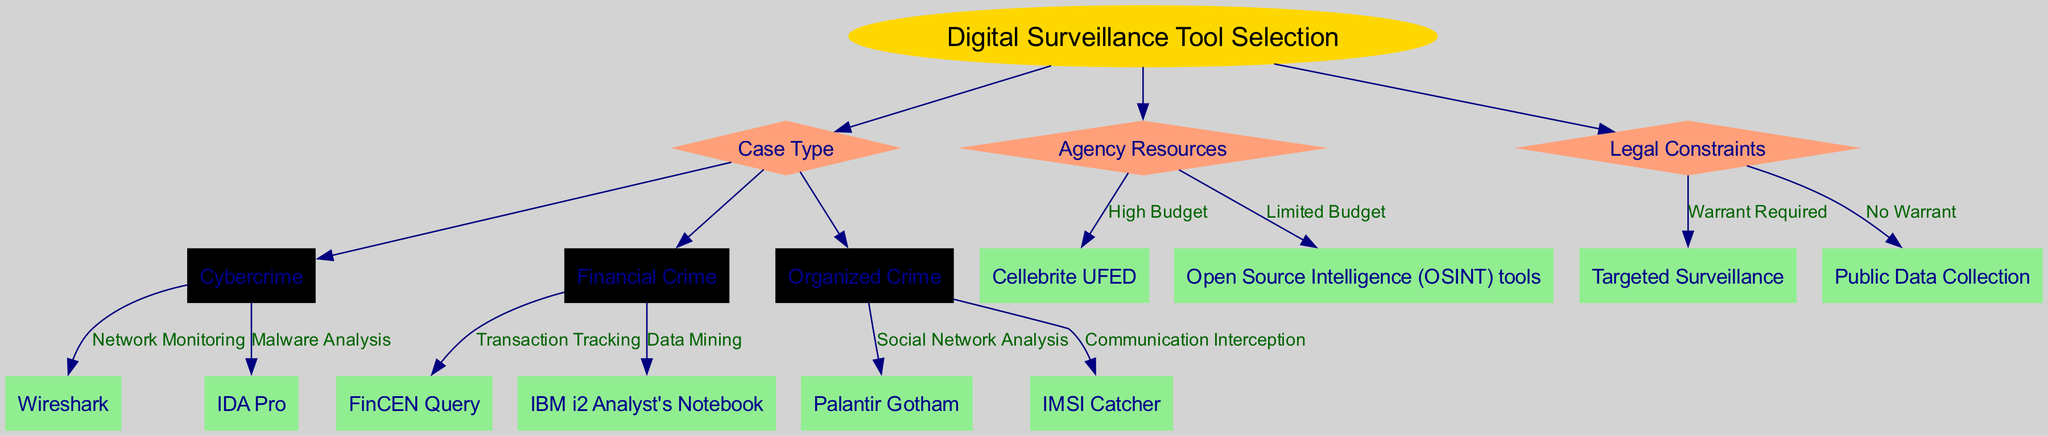What is the root node of the diagram? The root node of the diagram is labeled as "Digital Surveillance Tool Selection." This can be directly observed at the top of the diagram.
Answer: Digital Surveillance Tool Selection How many branches does the root node have? The root node has three branches: "Case Type," "Agency Resources," and "Legal Constraints." Counting these branches provides the answer.
Answer: 3 What is the tool listed under Cybercrime for Malware Analysis? The tool specified under Cybercrime for Malware Analysis is "IDA Pro." This information is directly found in the child nodes under the Cybercrime category.
Answer: IDA Pro Which node indicates that a warrant is required? The node indicating that a warrant is required is "Warrant Required." This can be found within the "Legal Constraints" branch of the diagram.
Answer: Warrant Required What is the surveillance tool for Organized Crime under Communication Interception? The surveillance tool for Organized Crime under Communication Interception is "IMSI Catcher." This can be seen in the child nodes under the Organized Crime category.
Answer: IMSI Catcher What type of budget category is recommended for Cellebrite UFED? The budget category recommended for Cellebrite UFED is "High Budget." This is evident as it is listed as the leaf under the Agency Resources branch for high budget scenarios.
Answer: High Budget Which digital surveillance tool should be selected under Limited Budget? The digital surveillance tool suggested under Limited Budget is "Open Source Intelligence (OSINT) tools." This is clear from the leaf node under the Agency Resources branch.
Answer: Open Source Intelligence (OSINT) tools What is the relationship between Case Type and Agency Resources in terms of surveillance tool selection? The relationship between Case Type and Agency Resources is that they are both primary branches stemming from the root node that help users identify specific surveillance tools. Each branch presents a different aspect of selection criteria. They work independently but contribute collectively to the selection process.
Answer: Independent branches What are the four surveillance tools mentioned throughout the diagram? The four surveillance tools identified in the diagram are "Wireshark," "IDA Pro," "Cellebrite UFED," and "Palantir Gotham." By systematically reviewing each branch, we can compile this list.
Answer: Wireshark, IDA Pro, Cellebrite UFED, Palantir Gotham 